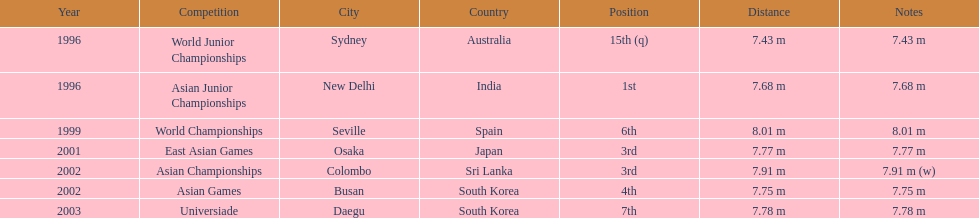What competitions did huang le compete in? World Junior Championships, Asian Junior Championships, World Championships, East Asian Games, Asian Championships, Asian Games, Universiade. What distances did he achieve in these competitions? 7.43 m, 7.68 m, 8.01 m, 7.77 m, 7.91 m (w), 7.75 m, 7.78 m. Which of these distances was the longest? 7.91 m (w). 